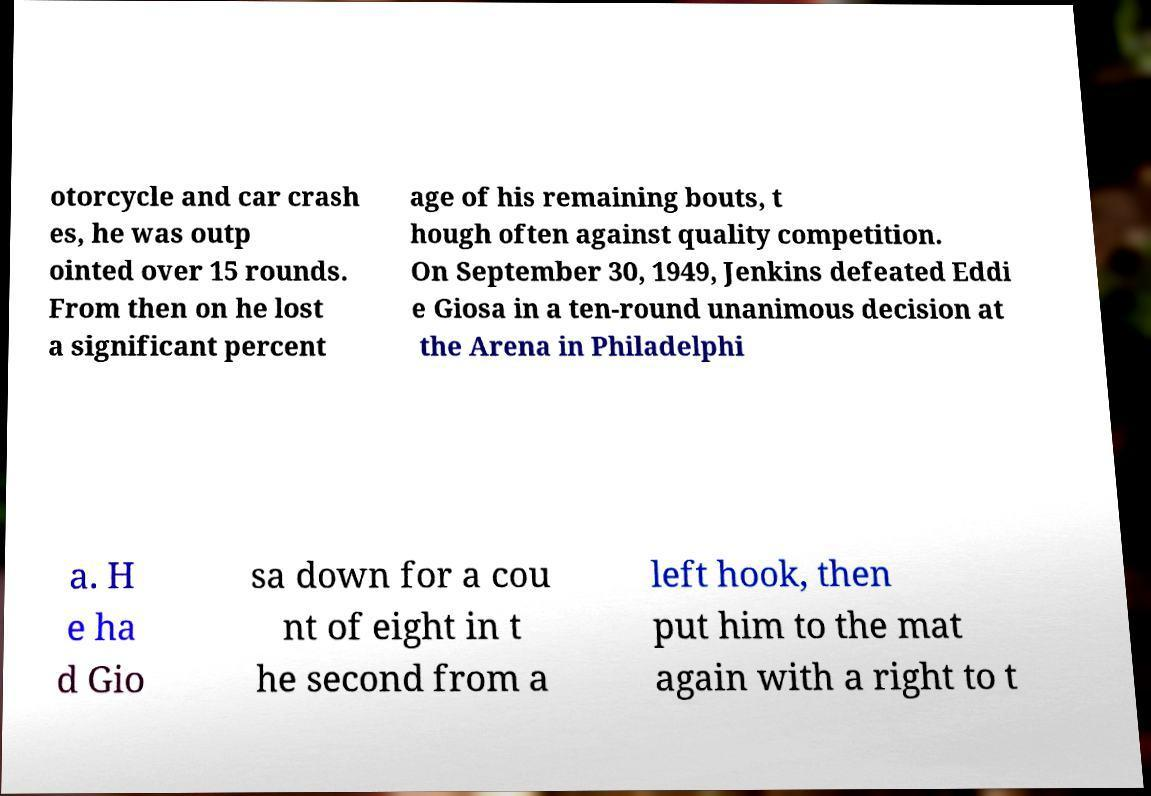Please read and relay the text visible in this image. What does it say? otorcycle and car crash es, he was outp ointed over 15 rounds. From then on he lost a significant percent age of his remaining bouts, t hough often against quality competition. On September 30, 1949, Jenkins defeated Eddi e Giosa in a ten-round unanimous decision at the Arena in Philadelphi a. H e ha d Gio sa down for a cou nt of eight in t he second from a left hook, then put him to the mat again with a right to t 